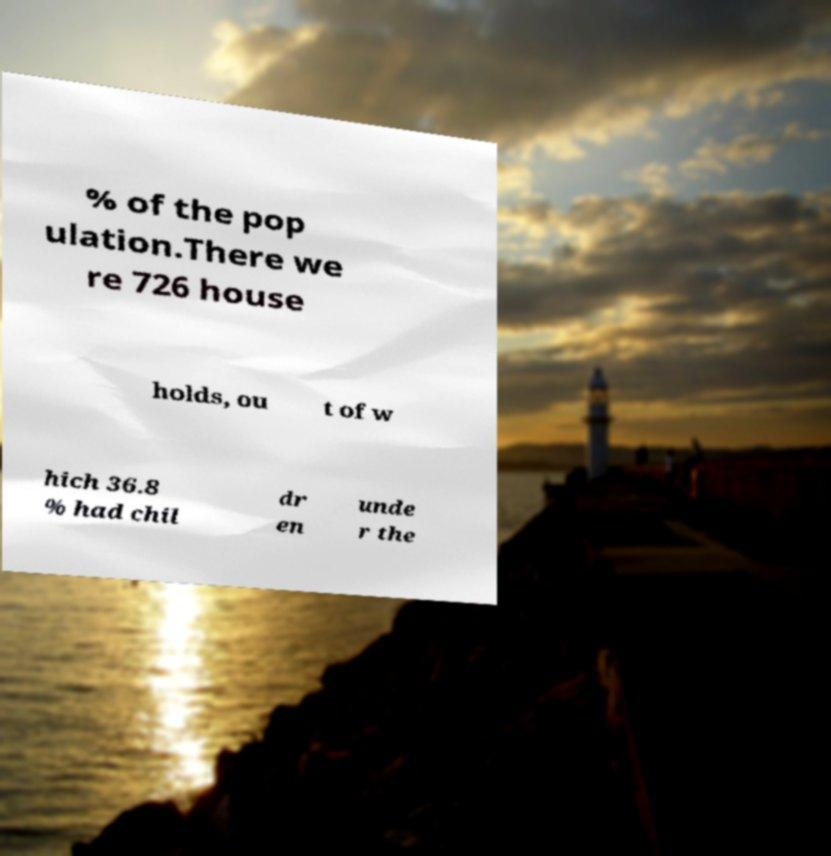Can you read and provide the text displayed in the image?This photo seems to have some interesting text. Can you extract and type it out for me? % of the pop ulation.There we re 726 house holds, ou t of w hich 36.8 % had chil dr en unde r the 